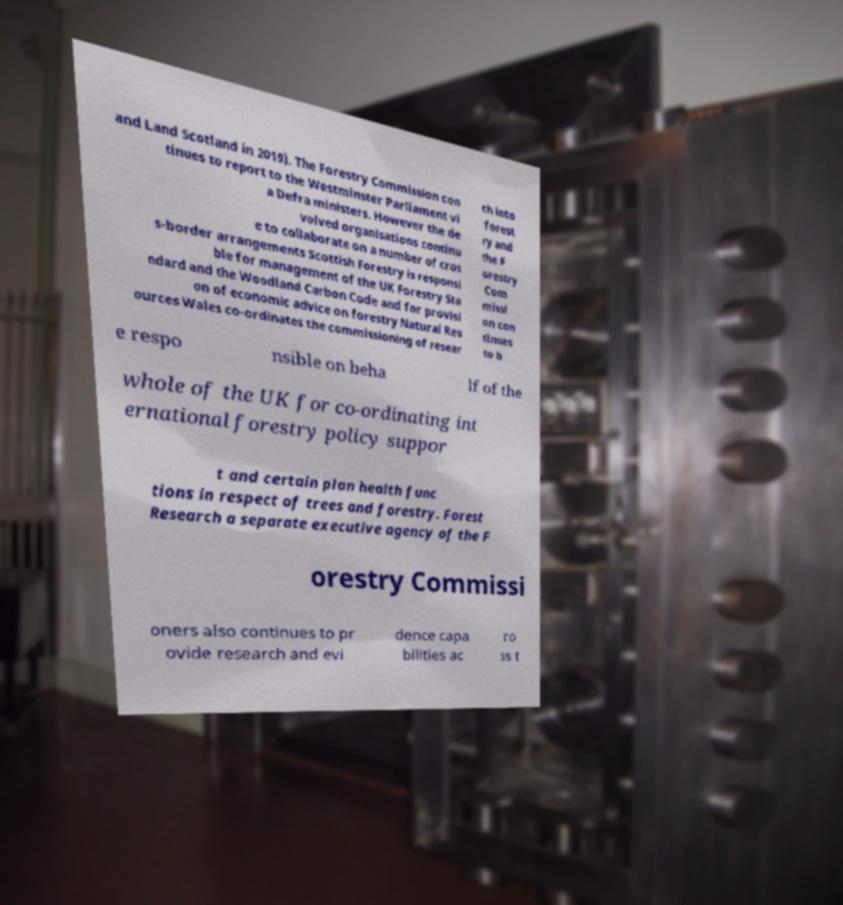Please read and relay the text visible in this image. What does it say? and Land Scotland in 2019). The Forestry Commission con tinues to report to the Westminster Parliament vi a Defra ministers. However the de volved organisations continu e to collaborate on a number of cros s-border arrangements Scottish Forestry is responsi ble for management of the UK Forestry Sta ndard and the Woodland Carbon Code and for provisi on of economic advice on forestry Natural Res ources Wales co-ordinates the commissioning of resear ch into forest ry and the F orestry Com missi on con tinues to b e respo nsible on beha lf of the whole of the UK for co-ordinating int ernational forestry policy suppor t and certain plan health func tions in respect of trees and forestry. Forest Research a separate executive agency of the F orestry Commissi oners also continues to pr ovide research and evi dence capa bilities ac ro ss t 